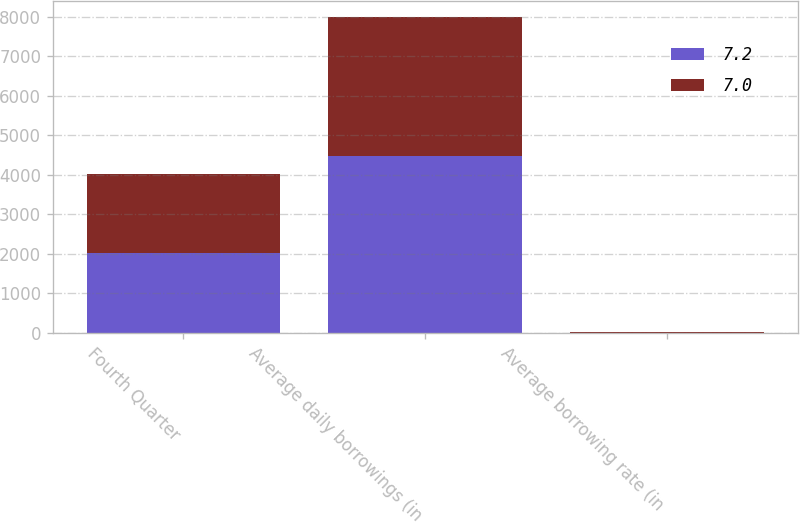Convert chart to OTSL. <chart><loc_0><loc_0><loc_500><loc_500><stacked_bar_chart><ecel><fcel>Fourth Quarter<fcel>Average daily borrowings (in<fcel>Average borrowing rate (in<nl><fcel>7.2<fcel>2012<fcel>4484<fcel>7<nl><fcel>7<fcel>2011<fcel>3520<fcel>7.2<nl></chart> 